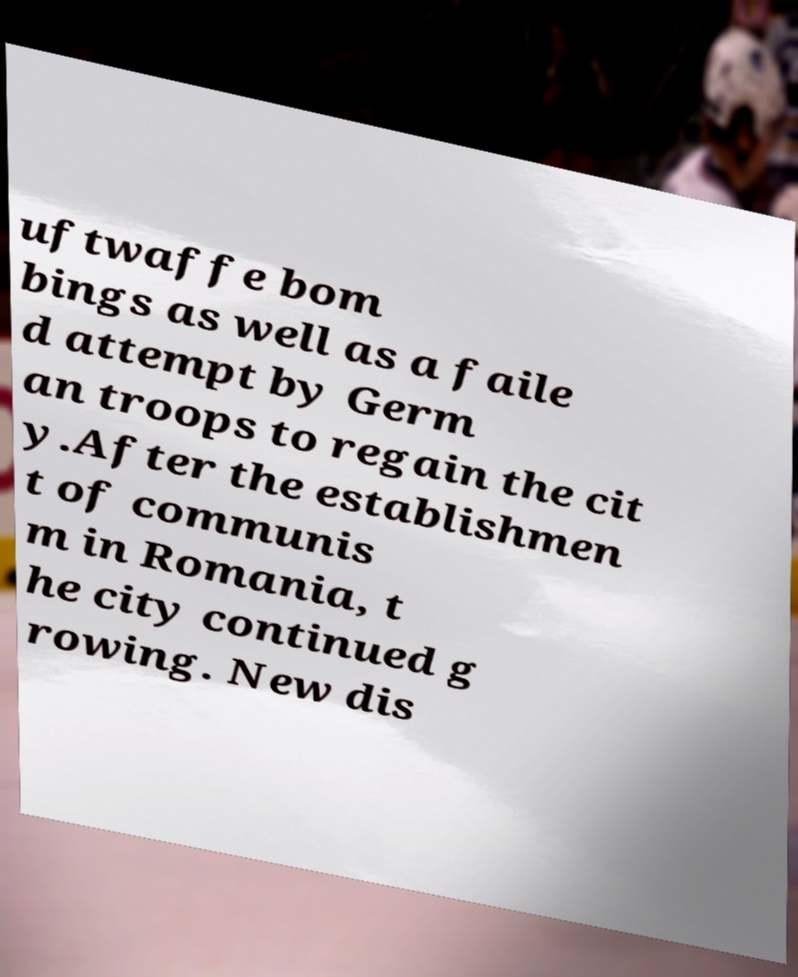Please read and relay the text visible in this image. What does it say? uftwaffe bom bings as well as a faile d attempt by Germ an troops to regain the cit y.After the establishmen t of communis m in Romania, t he city continued g rowing. New dis 